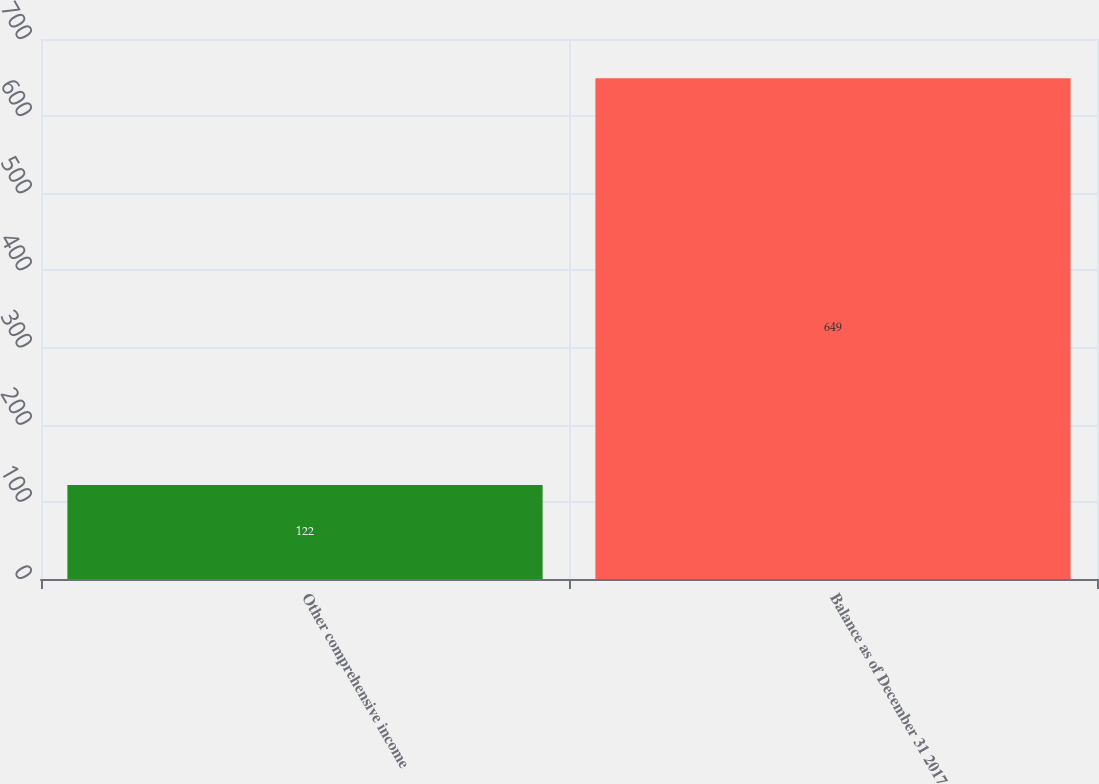Convert chart. <chart><loc_0><loc_0><loc_500><loc_500><bar_chart><fcel>Other comprehensive income<fcel>Balance as of December 31 2017<nl><fcel>122<fcel>649<nl></chart> 